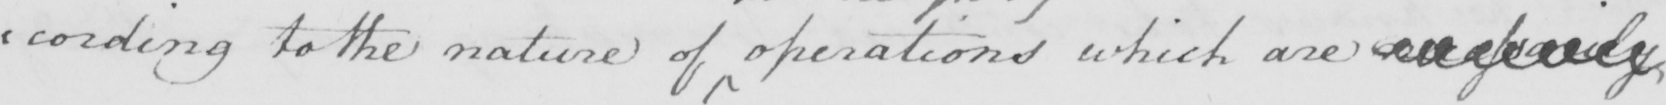What does this handwritten line say? : cording to the nature of operations which are necessarily 